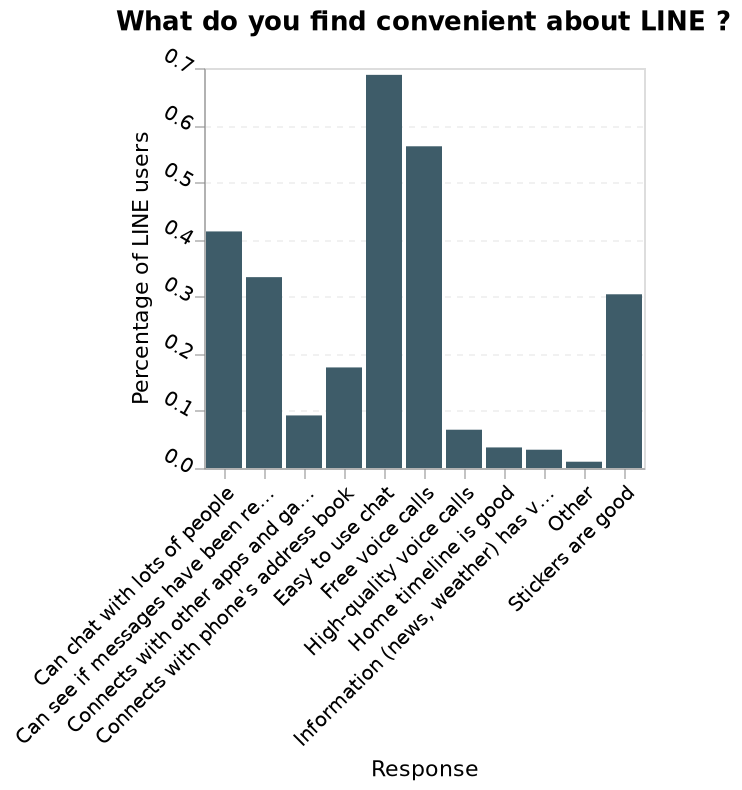<image>
Describe the following image in detail Here a is a bar plot labeled What do you find convenient about LINE ?. Percentage of LINE users is shown along a scale of range 0.0 to 0.7 on the y-axis. There is a categorical scale starting at Can chat with lots of people and ending at Stickers are good on the x-axis, marked Response. What does the x-axis represent on the bar plot?  The x-axis on the bar plot represents different categories, ranging from "Can chat with lots of people" to "Stickers are good", marked as "Response". What is the lowest value on the y-axis?  The lowest value on the y-axis is 0.0, which represents the lowest percentage of LINE users finding a certain convenience factor. please summary the statistics and relations of the chart What LINE users find most convenient is its easiness to use chat. LINE users find that the app is inconvenient at finding out information such as the weather or the news. What is being shown in the bar plot?  The bar plot shows the convenience factors of LINE, labeled "What do you find convenient about LINE?". It represents the percentage of LINE users who find different aspects convenient. 